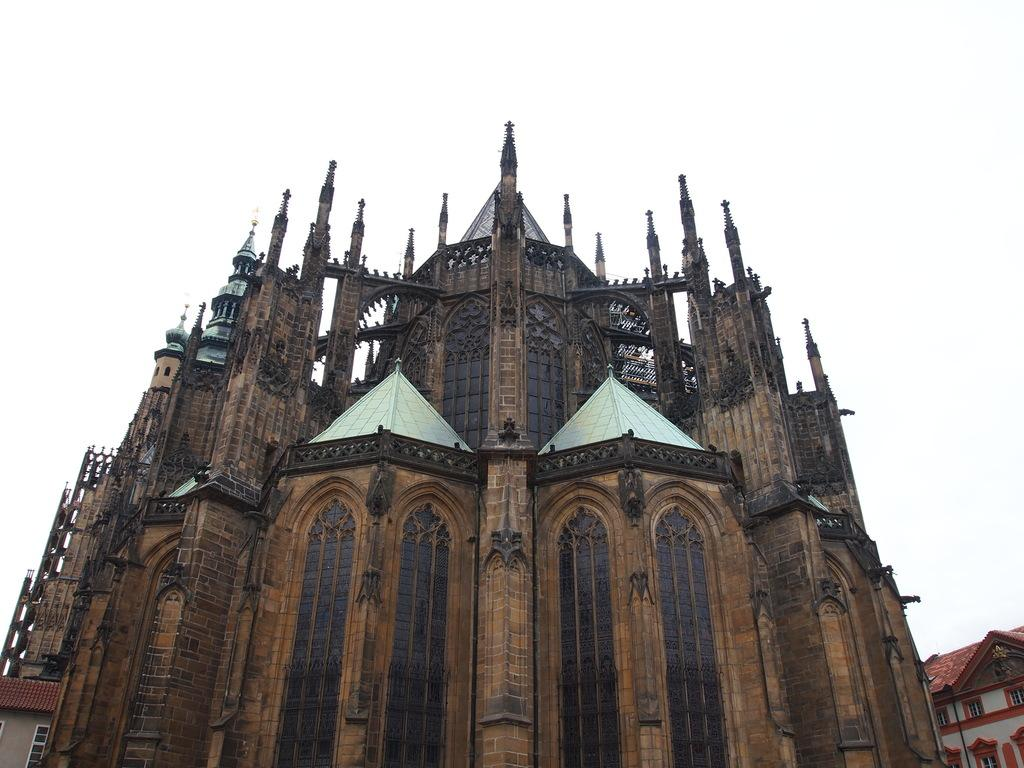What is the main structure in the center of the image? There is a building in the center of the image. What type of structures can be seen on the bottom sides of the image? There are houses on both the bottom sides of the image. What can be seen in the background of the image? The sky is visible in the background of the image. What type of thread is being used to hold the dinner in the image? There is no dinner present in the image, and therefore no thread is being used to hold it. 